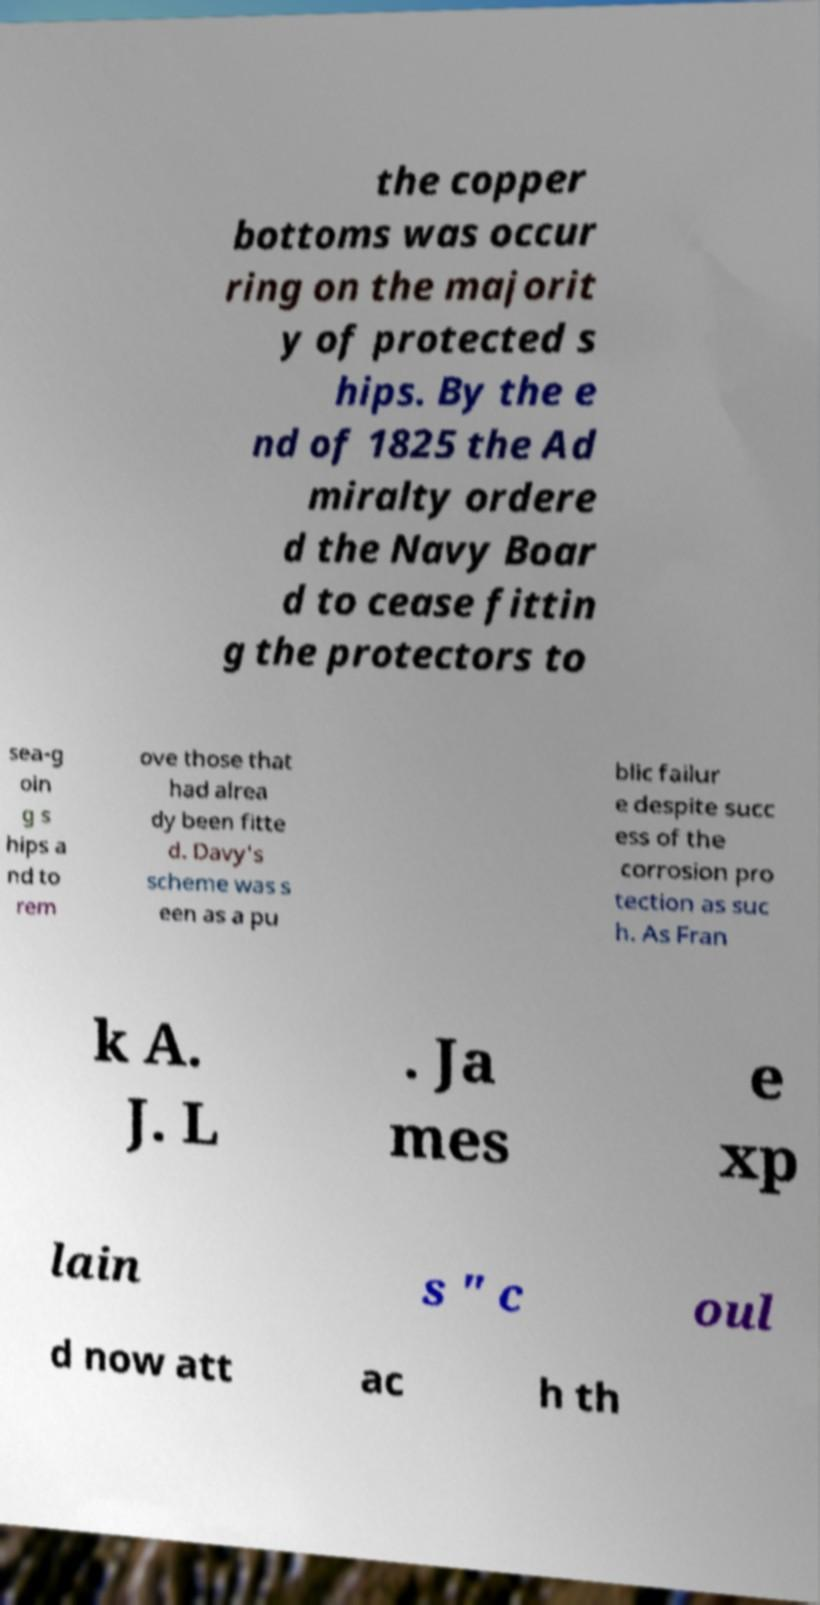Could you extract and type out the text from this image? the copper bottoms was occur ring on the majorit y of protected s hips. By the e nd of 1825 the Ad miralty ordere d the Navy Boar d to cease fittin g the protectors to sea-g oin g s hips a nd to rem ove those that had alrea dy been fitte d. Davy's scheme was s een as a pu blic failur e despite succ ess of the corrosion pro tection as suc h. As Fran k A. J. L . Ja mes e xp lain s " c oul d now att ac h th 